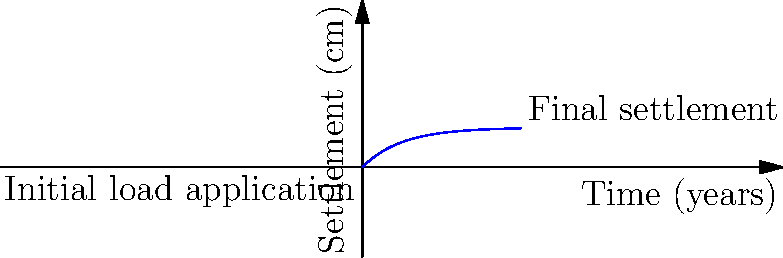A newly constructed research facility for studying dinosaur fossils is built on a clay layer. The foundation exerts a uniform pressure of 150 kPa on the soil. Given the consolidation curve shown in the graph, estimate the settlement of the structure after 10 years. Assume the initial settlement is negligible. To solve this problem, we'll follow these steps:

1) The consolidation curve follows the equation:
   $$S(t) = S_f(1-e^{-ct})$$
   where $S(t)$ is the settlement at time $t$, $S_f$ is the final settlement, and $c$ is the consolidation coefficient.

2) From the graph, we can see that $S_f = 5$ cm.

3) To find $c$, we can use a point on the curve. At $t=5$ years, $S \approx 3.9$ cm:
   $$3.9 = 5(1-e^{-5c})$$
   $$0.78 = 1-e^{-5c}$$
   $$e^{-5c} = 0.22$$
   $$-5c = \ln(0.22)$$
   $$c = -\frac{\ln(0.22)}{5} \approx 0.3$$

4) Now we can calculate the settlement at 10 years:
   $$S(10) = 5(1-e^{-0.3 \times 10})$$
   $$S(10) = 5(1-e^{-3})$$
   $$S(10) = 5(1-0.0498)$$
   $$S(10) = 5 \times 0.9502 = 4.751 \text{ cm}$$

5) Rounding to the nearest millimeter: 4.8 cm
Answer: 4.8 cm 